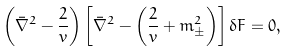<formula> <loc_0><loc_0><loc_500><loc_500>\left ( \bar { \nabla } ^ { 2 } - \frac { 2 } { v } \right ) \left [ \bar { \nabla } ^ { 2 } - \left ( \frac { 2 } { v } + m ^ { 2 } _ { \pm } \right ) \right ] \delta F = 0 ,</formula> 